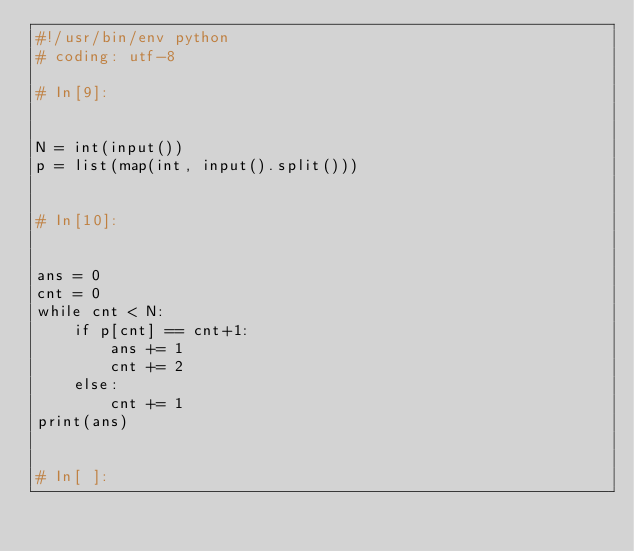Convert code to text. <code><loc_0><loc_0><loc_500><loc_500><_Python_>#!/usr/bin/env python
# coding: utf-8

# In[9]:


N = int(input())
p = list(map(int, input().split()))


# In[10]:


ans = 0
cnt = 0
while cnt < N:
    if p[cnt] == cnt+1:
        ans += 1
        cnt += 2
    else:
        cnt += 1
print(ans)


# In[ ]:




</code> 